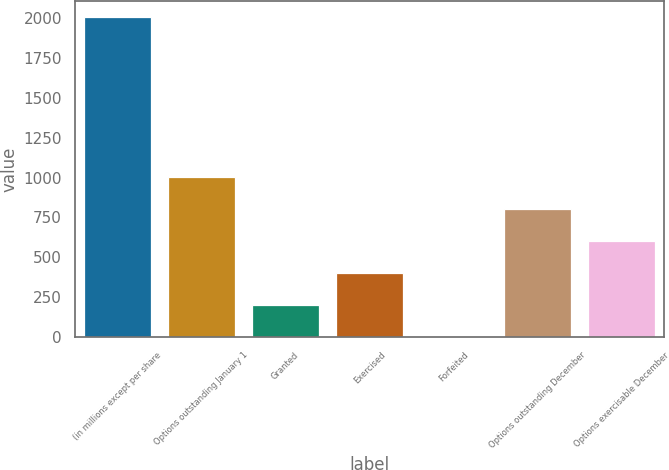Convert chart to OTSL. <chart><loc_0><loc_0><loc_500><loc_500><bar_chart><fcel>(in millions except per share<fcel>Options outstanding January 1<fcel>Granted<fcel>Exercised<fcel>Forfeited<fcel>Options outstanding December<fcel>Options exercisable December<nl><fcel>2006<fcel>1003.05<fcel>200.69<fcel>401.28<fcel>0.1<fcel>802.46<fcel>601.87<nl></chart> 